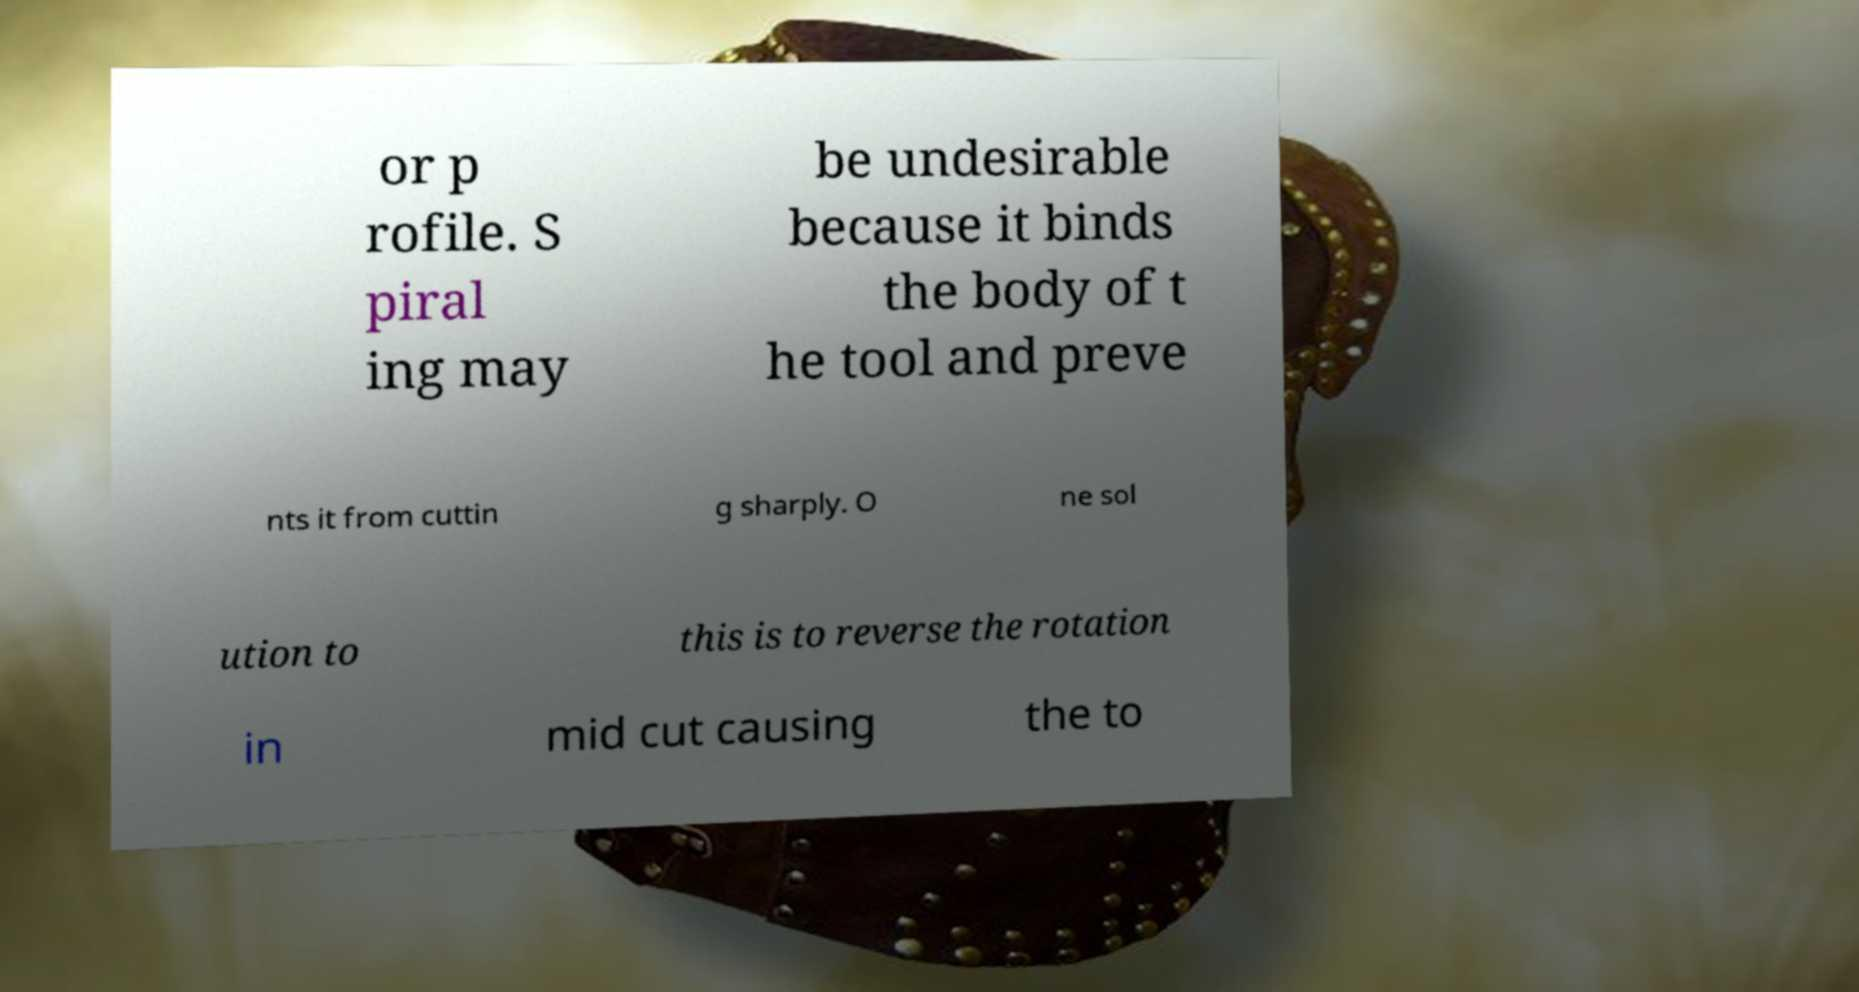Could you extract and type out the text from this image? or p rofile. S piral ing may be undesirable because it binds the body of t he tool and preve nts it from cuttin g sharply. O ne sol ution to this is to reverse the rotation in mid cut causing the to 